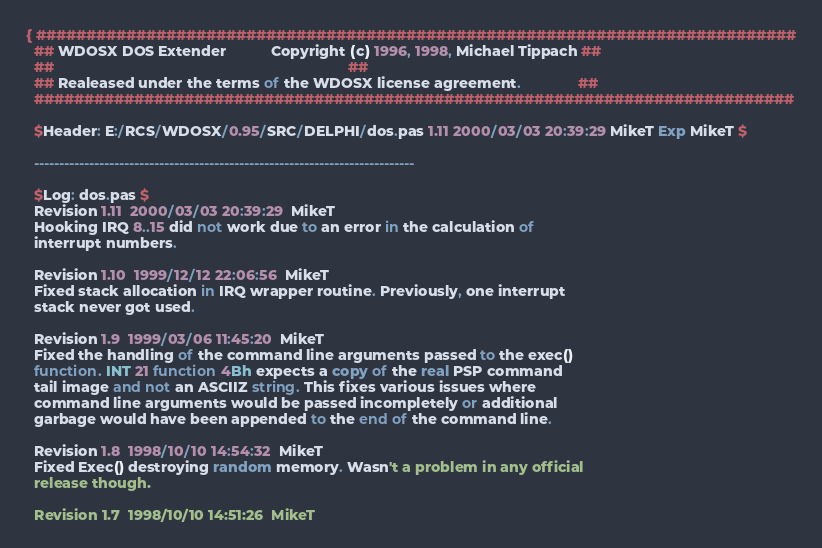Convert code to text. <code><loc_0><loc_0><loc_500><loc_500><_Pascal_>{ ############################################################################
  ## WDOSX DOS Extender           Copyright (c) 1996, 1998, Michael Tippach ##
  ##                                                                        ##
  ## Realeased under the terms of the WDOSX license agreement.              ##
  ############################################################################

  $Header: E:/RCS/WDOSX/0.95/SRC/DELPHI/dos.pas 1.11 2000/03/03 20:39:29 MikeT Exp MikeT $

  ----------------------------------------------------------------------------

  $Log: dos.pas $
  Revision 1.11  2000/03/03 20:39:29  MikeT
  Hooking IRQ 8..15 did not work due to an error in the calculation of
  interrupt numbers.

  Revision 1.10  1999/12/12 22:06:56  MikeT
  Fixed stack allocation in IRQ wrapper routine. Previously, one interrupt
  stack never got used.

  Revision 1.9  1999/03/06 11:45:20  MikeT
  Fixed the handling of the command line arguments passed to the exec()
  function. INT 21 function 4Bh expects a copy of the real PSP command
  tail image and not an ASCIIZ string. This fixes various issues where
  command line arguments would be passed incompletely or additional
  garbage would have been appended to the end of the command line.

  Revision 1.8  1998/10/10 14:54:32  MikeT
  Fixed Exec() destroying random memory. Wasn't a problem in any official
  release though.

  Revision 1.7  1998/10/10 14:51:26  MikeT</code> 